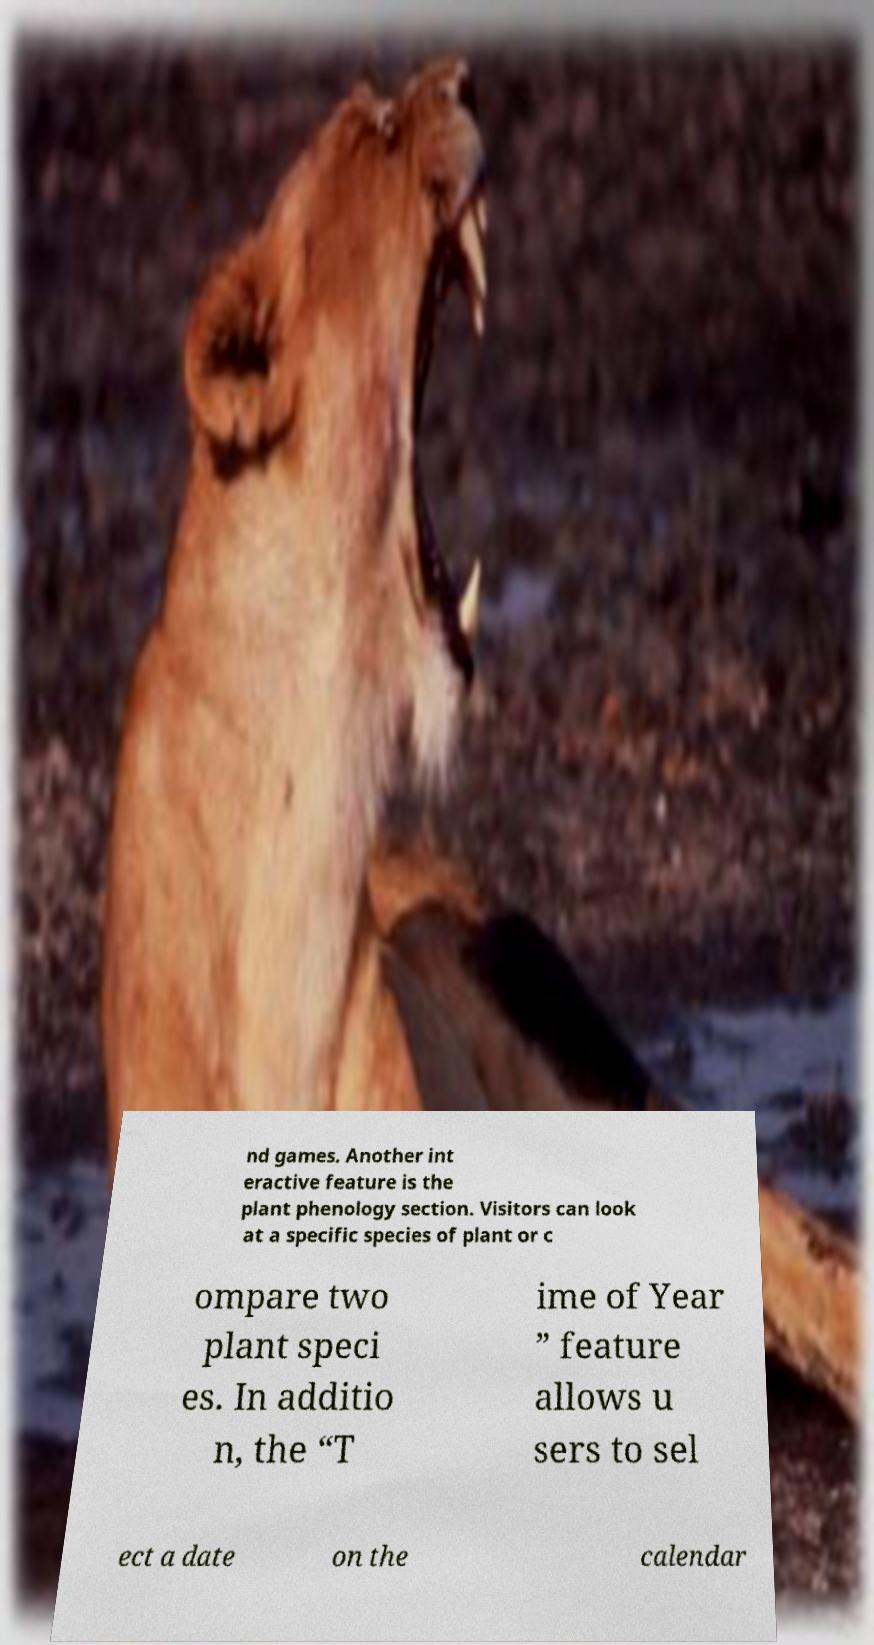Could you extract and type out the text from this image? nd games. Another int eractive feature is the plant phenology section. Visitors can look at a specific species of plant or c ompare two plant speci es. In additio n, the “T ime of Year ” feature allows u sers to sel ect a date on the calendar 